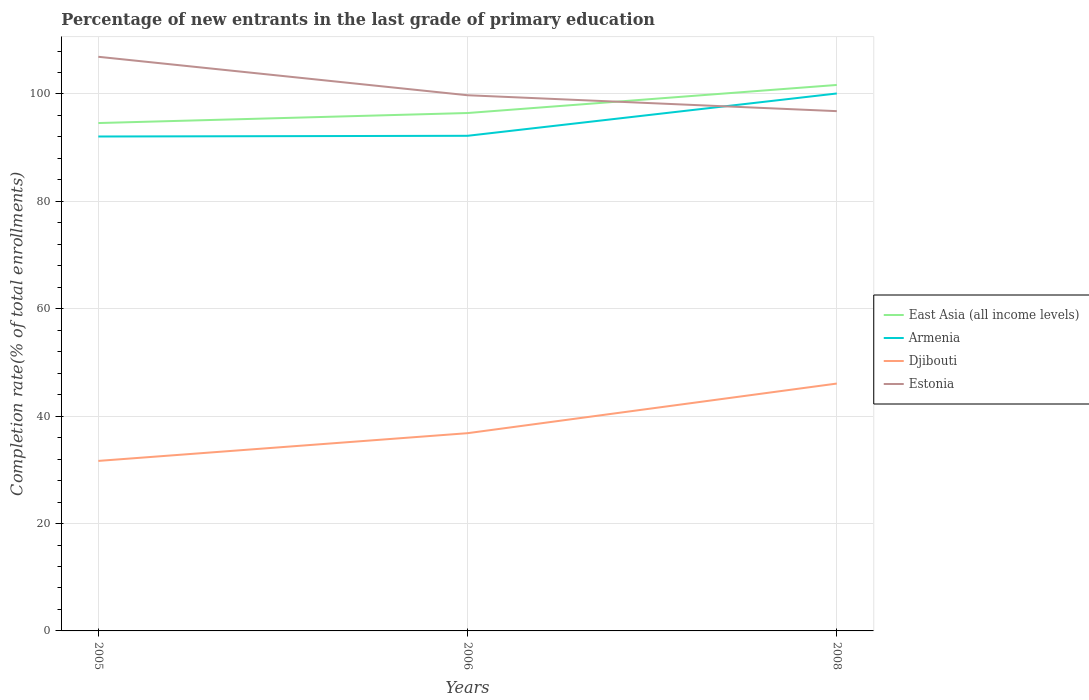Is the number of lines equal to the number of legend labels?
Ensure brevity in your answer.  Yes. Across all years, what is the maximum percentage of new entrants in Armenia?
Give a very brief answer. 92.08. In which year was the percentage of new entrants in Djibouti maximum?
Offer a terse response. 2005. What is the total percentage of new entrants in Estonia in the graph?
Offer a terse response. 2.96. What is the difference between the highest and the second highest percentage of new entrants in Estonia?
Make the answer very short. 10.13. What is the difference between the highest and the lowest percentage of new entrants in Armenia?
Your answer should be compact. 1. How many lines are there?
Give a very brief answer. 4. How many years are there in the graph?
Ensure brevity in your answer.  3. Does the graph contain grids?
Offer a terse response. Yes. Where does the legend appear in the graph?
Provide a short and direct response. Center right. How many legend labels are there?
Your response must be concise. 4. What is the title of the graph?
Provide a succinct answer. Percentage of new entrants in the last grade of primary education. Does "Japan" appear as one of the legend labels in the graph?
Provide a succinct answer. No. What is the label or title of the X-axis?
Give a very brief answer. Years. What is the label or title of the Y-axis?
Provide a short and direct response. Completion rate(% of total enrollments). What is the Completion rate(% of total enrollments) in East Asia (all income levels) in 2005?
Give a very brief answer. 94.59. What is the Completion rate(% of total enrollments) of Armenia in 2005?
Your response must be concise. 92.08. What is the Completion rate(% of total enrollments) in Djibouti in 2005?
Your answer should be compact. 31.66. What is the Completion rate(% of total enrollments) of Estonia in 2005?
Offer a terse response. 106.93. What is the Completion rate(% of total enrollments) in East Asia (all income levels) in 2006?
Offer a terse response. 96.45. What is the Completion rate(% of total enrollments) of Armenia in 2006?
Your answer should be compact. 92.21. What is the Completion rate(% of total enrollments) of Djibouti in 2006?
Keep it short and to the point. 36.83. What is the Completion rate(% of total enrollments) in Estonia in 2006?
Your answer should be very brief. 99.77. What is the Completion rate(% of total enrollments) in East Asia (all income levels) in 2008?
Your answer should be compact. 101.68. What is the Completion rate(% of total enrollments) in Armenia in 2008?
Make the answer very short. 100.1. What is the Completion rate(% of total enrollments) in Djibouti in 2008?
Make the answer very short. 46.07. What is the Completion rate(% of total enrollments) of Estonia in 2008?
Offer a terse response. 96.8. Across all years, what is the maximum Completion rate(% of total enrollments) of East Asia (all income levels)?
Keep it short and to the point. 101.68. Across all years, what is the maximum Completion rate(% of total enrollments) of Armenia?
Give a very brief answer. 100.1. Across all years, what is the maximum Completion rate(% of total enrollments) of Djibouti?
Make the answer very short. 46.07. Across all years, what is the maximum Completion rate(% of total enrollments) in Estonia?
Offer a terse response. 106.93. Across all years, what is the minimum Completion rate(% of total enrollments) of East Asia (all income levels)?
Your response must be concise. 94.59. Across all years, what is the minimum Completion rate(% of total enrollments) of Armenia?
Provide a short and direct response. 92.08. Across all years, what is the minimum Completion rate(% of total enrollments) in Djibouti?
Provide a succinct answer. 31.66. Across all years, what is the minimum Completion rate(% of total enrollments) of Estonia?
Offer a very short reply. 96.8. What is the total Completion rate(% of total enrollments) in East Asia (all income levels) in the graph?
Ensure brevity in your answer.  292.72. What is the total Completion rate(% of total enrollments) of Armenia in the graph?
Your response must be concise. 284.39. What is the total Completion rate(% of total enrollments) of Djibouti in the graph?
Ensure brevity in your answer.  114.56. What is the total Completion rate(% of total enrollments) in Estonia in the graph?
Provide a succinct answer. 303.5. What is the difference between the Completion rate(% of total enrollments) in East Asia (all income levels) in 2005 and that in 2006?
Provide a succinct answer. -1.87. What is the difference between the Completion rate(% of total enrollments) in Armenia in 2005 and that in 2006?
Your response must be concise. -0.13. What is the difference between the Completion rate(% of total enrollments) in Djibouti in 2005 and that in 2006?
Give a very brief answer. -5.16. What is the difference between the Completion rate(% of total enrollments) of Estonia in 2005 and that in 2006?
Offer a terse response. 7.16. What is the difference between the Completion rate(% of total enrollments) in East Asia (all income levels) in 2005 and that in 2008?
Make the answer very short. -7.09. What is the difference between the Completion rate(% of total enrollments) in Armenia in 2005 and that in 2008?
Offer a very short reply. -8.01. What is the difference between the Completion rate(% of total enrollments) of Djibouti in 2005 and that in 2008?
Give a very brief answer. -14.41. What is the difference between the Completion rate(% of total enrollments) in Estonia in 2005 and that in 2008?
Ensure brevity in your answer.  10.13. What is the difference between the Completion rate(% of total enrollments) in East Asia (all income levels) in 2006 and that in 2008?
Ensure brevity in your answer.  -5.23. What is the difference between the Completion rate(% of total enrollments) of Armenia in 2006 and that in 2008?
Provide a succinct answer. -7.88. What is the difference between the Completion rate(% of total enrollments) of Djibouti in 2006 and that in 2008?
Your response must be concise. -9.24. What is the difference between the Completion rate(% of total enrollments) in Estonia in 2006 and that in 2008?
Offer a very short reply. 2.96. What is the difference between the Completion rate(% of total enrollments) of East Asia (all income levels) in 2005 and the Completion rate(% of total enrollments) of Armenia in 2006?
Offer a very short reply. 2.38. What is the difference between the Completion rate(% of total enrollments) in East Asia (all income levels) in 2005 and the Completion rate(% of total enrollments) in Djibouti in 2006?
Your answer should be compact. 57.76. What is the difference between the Completion rate(% of total enrollments) in East Asia (all income levels) in 2005 and the Completion rate(% of total enrollments) in Estonia in 2006?
Provide a short and direct response. -5.18. What is the difference between the Completion rate(% of total enrollments) of Armenia in 2005 and the Completion rate(% of total enrollments) of Djibouti in 2006?
Your answer should be very brief. 55.25. What is the difference between the Completion rate(% of total enrollments) in Armenia in 2005 and the Completion rate(% of total enrollments) in Estonia in 2006?
Provide a short and direct response. -7.68. What is the difference between the Completion rate(% of total enrollments) in Djibouti in 2005 and the Completion rate(% of total enrollments) in Estonia in 2006?
Your answer should be very brief. -68.1. What is the difference between the Completion rate(% of total enrollments) in East Asia (all income levels) in 2005 and the Completion rate(% of total enrollments) in Armenia in 2008?
Make the answer very short. -5.51. What is the difference between the Completion rate(% of total enrollments) in East Asia (all income levels) in 2005 and the Completion rate(% of total enrollments) in Djibouti in 2008?
Provide a succinct answer. 48.52. What is the difference between the Completion rate(% of total enrollments) in East Asia (all income levels) in 2005 and the Completion rate(% of total enrollments) in Estonia in 2008?
Offer a very short reply. -2.22. What is the difference between the Completion rate(% of total enrollments) in Armenia in 2005 and the Completion rate(% of total enrollments) in Djibouti in 2008?
Provide a short and direct response. 46.01. What is the difference between the Completion rate(% of total enrollments) in Armenia in 2005 and the Completion rate(% of total enrollments) in Estonia in 2008?
Offer a very short reply. -4.72. What is the difference between the Completion rate(% of total enrollments) in Djibouti in 2005 and the Completion rate(% of total enrollments) in Estonia in 2008?
Provide a short and direct response. -65.14. What is the difference between the Completion rate(% of total enrollments) of East Asia (all income levels) in 2006 and the Completion rate(% of total enrollments) of Armenia in 2008?
Ensure brevity in your answer.  -3.64. What is the difference between the Completion rate(% of total enrollments) of East Asia (all income levels) in 2006 and the Completion rate(% of total enrollments) of Djibouti in 2008?
Give a very brief answer. 50.38. What is the difference between the Completion rate(% of total enrollments) of East Asia (all income levels) in 2006 and the Completion rate(% of total enrollments) of Estonia in 2008?
Offer a very short reply. -0.35. What is the difference between the Completion rate(% of total enrollments) of Armenia in 2006 and the Completion rate(% of total enrollments) of Djibouti in 2008?
Give a very brief answer. 46.14. What is the difference between the Completion rate(% of total enrollments) of Armenia in 2006 and the Completion rate(% of total enrollments) of Estonia in 2008?
Offer a terse response. -4.59. What is the difference between the Completion rate(% of total enrollments) in Djibouti in 2006 and the Completion rate(% of total enrollments) in Estonia in 2008?
Give a very brief answer. -59.98. What is the average Completion rate(% of total enrollments) of East Asia (all income levels) per year?
Give a very brief answer. 97.57. What is the average Completion rate(% of total enrollments) of Armenia per year?
Make the answer very short. 94.8. What is the average Completion rate(% of total enrollments) of Djibouti per year?
Ensure brevity in your answer.  38.19. What is the average Completion rate(% of total enrollments) in Estonia per year?
Your answer should be compact. 101.17. In the year 2005, what is the difference between the Completion rate(% of total enrollments) of East Asia (all income levels) and Completion rate(% of total enrollments) of Armenia?
Give a very brief answer. 2.51. In the year 2005, what is the difference between the Completion rate(% of total enrollments) in East Asia (all income levels) and Completion rate(% of total enrollments) in Djibouti?
Your response must be concise. 62.92. In the year 2005, what is the difference between the Completion rate(% of total enrollments) in East Asia (all income levels) and Completion rate(% of total enrollments) in Estonia?
Ensure brevity in your answer.  -12.34. In the year 2005, what is the difference between the Completion rate(% of total enrollments) in Armenia and Completion rate(% of total enrollments) in Djibouti?
Your response must be concise. 60.42. In the year 2005, what is the difference between the Completion rate(% of total enrollments) in Armenia and Completion rate(% of total enrollments) in Estonia?
Give a very brief answer. -14.85. In the year 2005, what is the difference between the Completion rate(% of total enrollments) of Djibouti and Completion rate(% of total enrollments) of Estonia?
Offer a terse response. -75.26. In the year 2006, what is the difference between the Completion rate(% of total enrollments) in East Asia (all income levels) and Completion rate(% of total enrollments) in Armenia?
Provide a short and direct response. 4.24. In the year 2006, what is the difference between the Completion rate(% of total enrollments) in East Asia (all income levels) and Completion rate(% of total enrollments) in Djibouti?
Offer a terse response. 59.63. In the year 2006, what is the difference between the Completion rate(% of total enrollments) of East Asia (all income levels) and Completion rate(% of total enrollments) of Estonia?
Make the answer very short. -3.31. In the year 2006, what is the difference between the Completion rate(% of total enrollments) in Armenia and Completion rate(% of total enrollments) in Djibouti?
Your answer should be compact. 55.38. In the year 2006, what is the difference between the Completion rate(% of total enrollments) in Armenia and Completion rate(% of total enrollments) in Estonia?
Your answer should be compact. -7.55. In the year 2006, what is the difference between the Completion rate(% of total enrollments) in Djibouti and Completion rate(% of total enrollments) in Estonia?
Offer a terse response. -62.94. In the year 2008, what is the difference between the Completion rate(% of total enrollments) in East Asia (all income levels) and Completion rate(% of total enrollments) in Armenia?
Your answer should be compact. 1.59. In the year 2008, what is the difference between the Completion rate(% of total enrollments) of East Asia (all income levels) and Completion rate(% of total enrollments) of Djibouti?
Offer a very short reply. 55.61. In the year 2008, what is the difference between the Completion rate(% of total enrollments) in East Asia (all income levels) and Completion rate(% of total enrollments) in Estonia?
Offer a terse response. 4.88. In the year 2008, what is the difference between the Completion rate(% of total enrollments) of Armenia and Completion rate(% of total enrollments) of Djibouti?
Provide a short and direct response. 54.02. In the year 2008, what is the difference between the Completion rate(% of total enrollments) of Armenia and Completion rate(% of total enrollments) of Estonia?
Provide a succinct answer. 3.29. In the year 2008, what is the difference between the Completion rate(% of total enrollments) in Djibouti and Completion rate(% of total enrollments) in Estonia?
Your answer should be compact. -50.73. What is the ratio of the Completion rate(% of total enrollments) of East Asia (all income levels) in 2005 to that in 2006?
Keep it short and to the point. 0.98. What is the ratio of the Completion rate(% of total enrollments) of Djibouti in 2005 to that in 2006?
Offer a very short reply. 0.86. What is the ratio of the Completion rate(% of total enrollments) of Estonia in 2005 to that in 2006?
Your answer should be very brief. 1.07. What is the ratio of the Completion rate(% of total enrollments) in East Asia (all income levels) in 2005 to that in 2008?
Keep it short and to the point. 0.93. What is the ratio of the Completion rate(% of total enrollments) of Armenia in 2005 to that in 2008?
Keep it short and to the point. 0.92. What is the ratio of the Completion rate(% of total enrollments) in Djibouti in 2005 to that in 2008?
Offer a very short reply. 0.69. What is the ratio of the Completion rate(% of total enrollments) in Estonia in 2005 to that in 2008?
Offer a terse response. 1.1. What is the ratio of the Completion rate(% of total enrollments) in East Asia (all income levels) in 2006 to that in 2008?
Keep it short and to the point. 0.95. What is the ratio of the Completion rate(% of total enrollments) in Armenia in 2006 to that in 2008?
Offer a terse response. 0.92. What is the ratio of the Completion rate(% of total enrollments) in Djibouti in 2006 to that in 2008?
Keep it short and to the point. 0.8. What is the ratio of the Completion rate(% of total enrollments) in Estonia in 2006 to that in 2008?
Ensure brevity in your answer.  1.03. What is the difference between the highest and the second highest Completion rate(% of total enrollments) in East Asia (all income levels)?
Your answer should be compact. 5.23. What is the difference between the highest and the second highest Completion rate(% of total enrollments) in Armenia?
Offer a very short reply. 7.88. What is the difference between the highest and the second highest Completion rate(% of total enrollments) of Djibouti?
Your answer should be compact. 9.24. What is the difference between the highest and the second highest Completion rate(% of total enrollments) of Estonia?
Provide a short and direct response. 7.16. What is the difference between the highest and the lowest Completion rate(% of total enrollments) of East Asia (all income levels)?
Make the answer very short. 7.09. What is the difference between the highest and the lowest Completion rate(% of total enrollments) in Armenia?
Make the answer very short. 8.01. What is the difference between the highest and the lowest Completion rate(% of total enrollments) in Djibouti?
Keep it short and to the point. 14.41. What is the difference between the highest and the lowest Completion rate(% of total enrollments) of Estonia?
Give a very brief answer. 10.13. 